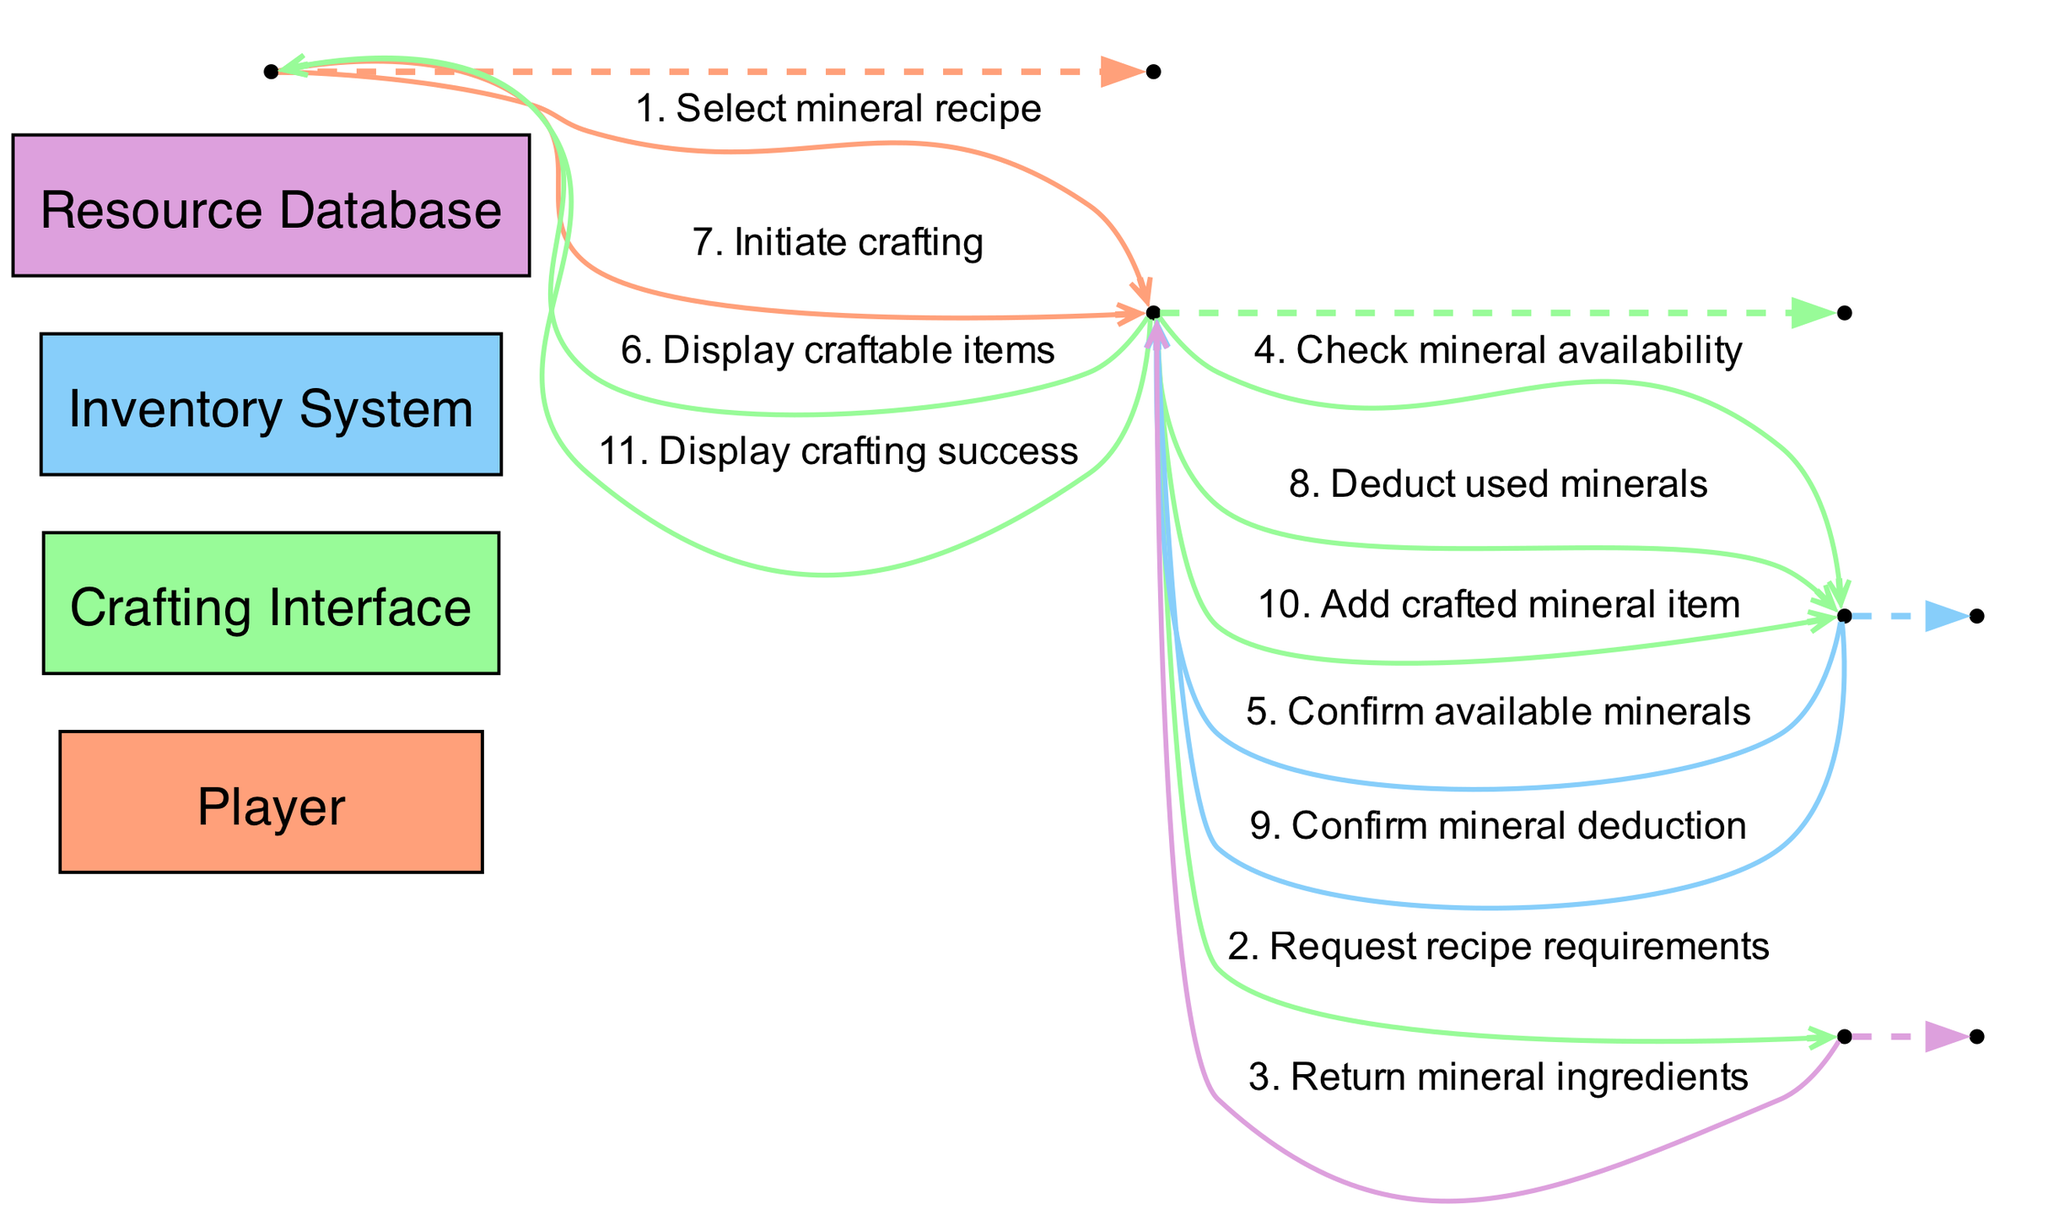What is the first action taken by the Player? The Player selects a mineral recipe from the Crafting Interface, which is represented as the first interaction in the diagram.
Answer: Select mineral recipe How many actors are involved in this crafting system? The diagram lists four distinct actors: Player, Crafting Interface, Inventory System, and Resource Database.
Answer: Four What message does the Crafting Interface send to the Resource Database? The Crafting Interface requests the recipe requirements from the Resource Database, which is shown as the second interaction in the flow of the diagram.
Answer: Request recipe requirements Which system confirms available minerals to the Crafting Interface? The Inventory System is responsible for confirming the availability of minerals to the Crafting Interface after checking the inventory.
Answer: Inventory System What happens after the Player initiates crafting? After the Player initiates crafting, the Crafting Interface deducts the used minerals from the Inventory System, which follows the Player's action within the sequence.
Answer: Deduct used minerals Which message is displayed to the Player after crafting is completed? Upon successful crafting, the Crafting Interface displays the crafting success to the Player, indicating a positive outcome of the crafting process.
Answer: Display crafting success In what order do the interactions from Player to Crafting Interface occur? The interactions between the Player and the Crafting Interface occur first with selecting a recipe, followed by initiating the crafting process. The sequence indicates these are the first and sixth interactions, respectively.
Answer: Select mineral recipe, Initiate crafting What action follows the confirmation of mineral deduction? After the Inventory System confirms the mineral deduction, the Crafting Interface then adds the crafted mineral item to the Inventory System, which reflects the outcome of the crafting process.
Answer: Add crafted mineral item What type of message does the Resource Database send back to the Crafting Interface? The Resource Database returns mineral ingredients in response to the request for recipe requirements, which is characterized as a returning message in the diagram.
Answer: Return mineral ingredients 